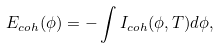<formula> <loc_0><loc_0><loc_500><loc_500>E _ { c o h } ( \phi ) = - \int I _ { c o h } ( \phi , T ) d \phi ,</formula> 